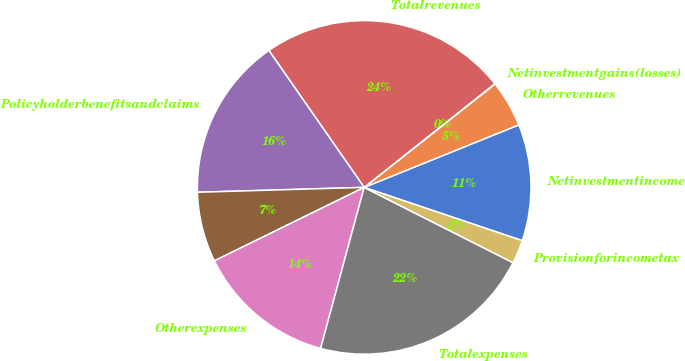Convert chart to OTSL. <chart><loc_0><loc_0><loc_500><loc_500><pie_chart><fcel>Netinvestmentincome<fcel>Otherrevenues<fcel>Netinvestmentgains(losses)<fcel>Totalrevenues<fcel>Policyholderbenefitsandclaims<fcel>Unnamed: 5<fcel>Otherexpenses<fcel>Totalexpenses<fcel>Provisionforincometax<nl><fcel>11.29%<fcel>4.53%<fcel>0.03%<fcel>24.0%<fcel>15.79%<fcel>6.79%<fcel>13.54%<fcel>21.75%<fcel>2.28%<nl></chart> 